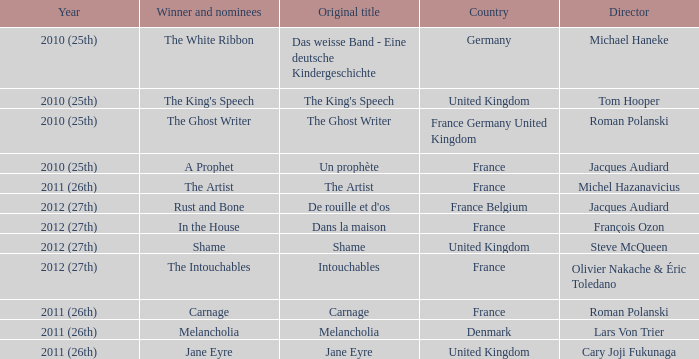Who was the winner and nominees for the movie directed by cary joji fukunaga? Jane Eyre. 